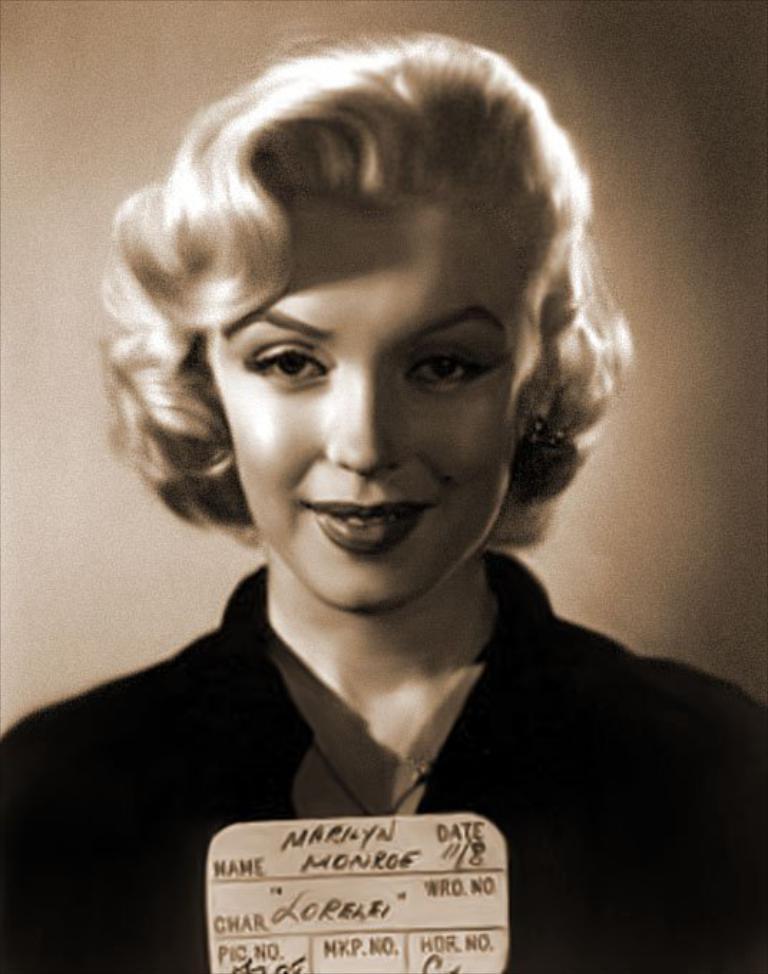Please provide a concise description of this image. In this image I see a woman who is smiling and I see a paper on which there is something written and it is brown and dark in the background. 